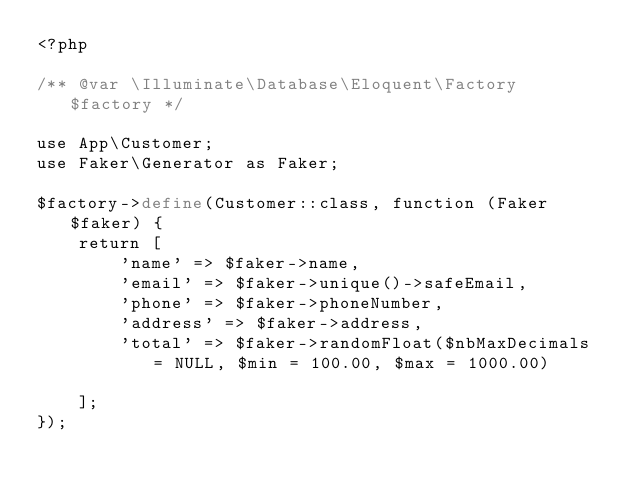Convert code to text. <code><loc_0><loc_0><loc_500><loc_500><_PHP_><?php

/** @var \Illuminate\Database\Eloquent\Factory $factory */

use App\Customer;
use Faker\Generator as Faker;

$factory->define(Customer::class, function (Faker $faker) {
    return [
        'name' => $faker->name,
        'email' => $faker->unique()->safeEmail,
        'phone' => $faker->phoneNumber,
        'address' => $faker->address,
        'total' => $faker->randomFloat($nbMaxDecimals = NULL, $min = 100.00, $max = 1000.00)

    ];
});
</code> 